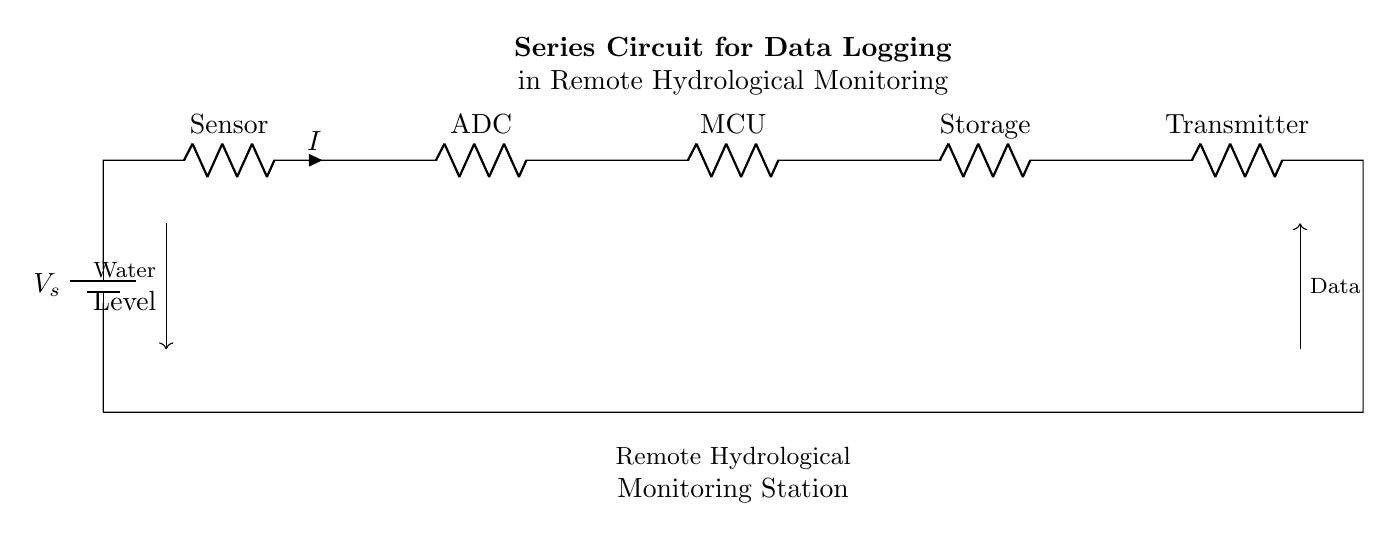What is the total number of components in the circuit? The circuit diagram shows a total of six components: a battery, a sensor, an ADC, an MCU, storage, and a transmitter. Each of these components is connected in series.
Answer: six What is the function of the ADC in this circuit? The ADC (Analog-to-Digital Converter) converts the analog signal from the sensor into a digital signal, which can then be processed by the MCU. This is essential for data logging and analysis purposes in the monitoring station.
Answer: conversion What is the main purpose of this series circuit? The main purpose of the series circuit is to facilitate data logging for a remote hydrological monitoring station by processing water level data. Each component plays a role in sensing, processing, storing, and transmitting data.
Answer: data logging What is the direction of data flow in this circuit? The data flow is from the sensor through the ADC to the MCU, then to storage and finally to the transmitter. The arrows in the diagram indicate the flow direction, which starts at the water level sensor and ends at the data transmitter.
Answer: sensor to transmitter How does the voltage across each component relate in a series circuit? In a series circuit, the total voltage supplied by the battery is divided among all the components. The sum of the voltages across each component equals the total voltage, ensuring that the same current flows through all components in the series.
Answer: divided What component serves as the power source in this circuit? The battery labeled as V_s serves as the power source, providing the necessary voltage for the entire circuit operation. This is the component that supplies energy to drive the current through the other components.
Answer: battery 